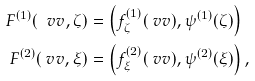<formula> <loc_0><loc_0><loc_500><loc_500>F ^ { ( 1 ) } ( \ v v , \zeta ) & = \left ( f ^ { ( 1 ) } _ { \zeta } ( \ v v ) , \psi ^ { ( 1 ) } ( \zeta ) \right ) \\ F ^ { ( 2 ) } ( \ v v , \xi ) & = \left ( f ^ { ( 2 ) } _ { \xi } ( \ v v ) , \psi ^ { ( 2 ) } ( \xi ) \right ) ,</formula> 